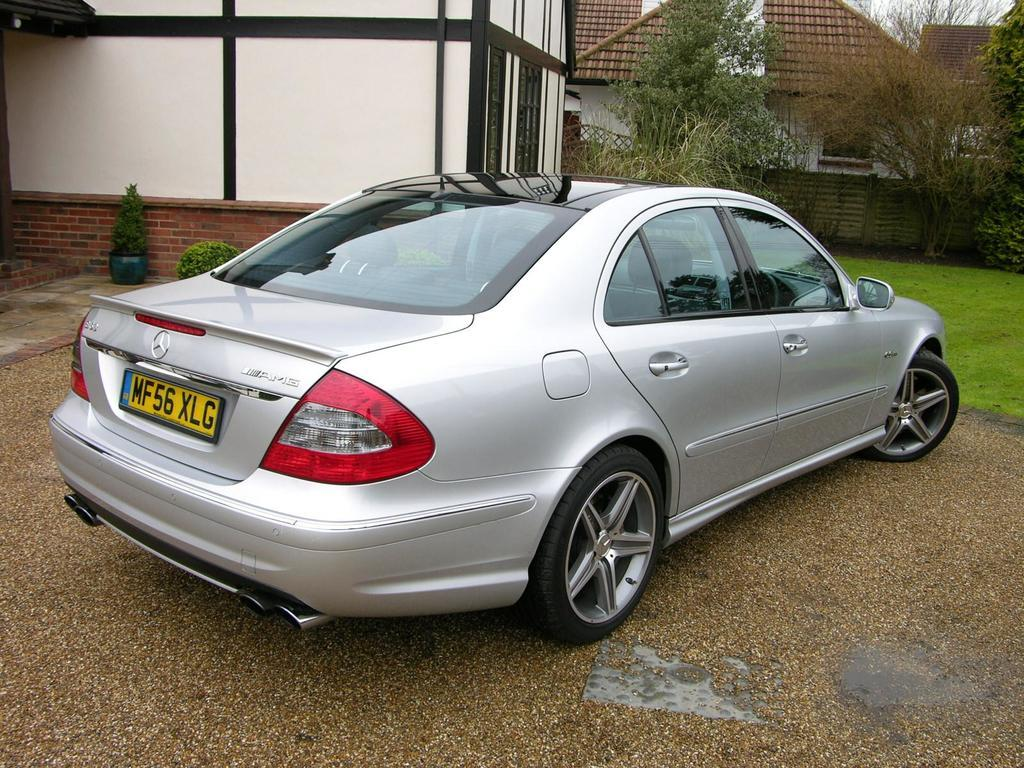What type of structures can be seen in the image? There are houses in the image. What type of vegetation is present in the image? There are plants and grass in the image. What type of terrain is visible in the image? There is sand in the image. What type of vehicle is present in the image? There is a car in the image. What type of material is used to create an object in the image? There is a wooden object in the image. Who is the friend that is sitting on the wooden object in the image? There is no friend sitting on the wooden object in the image; it is a standalone object. What type of ice can be seen melting on the car in the image? There is no ice present on the car in the image. 